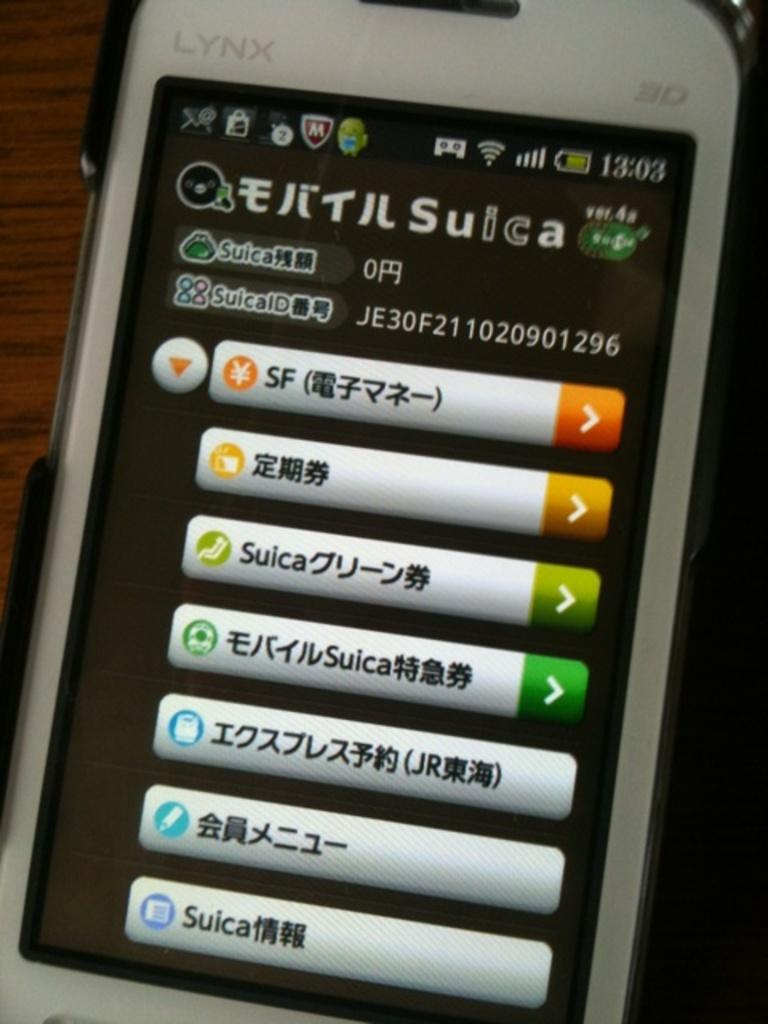<image>
Summarize the visual content of the image. a phone with japanese or chinese language displayed on it 